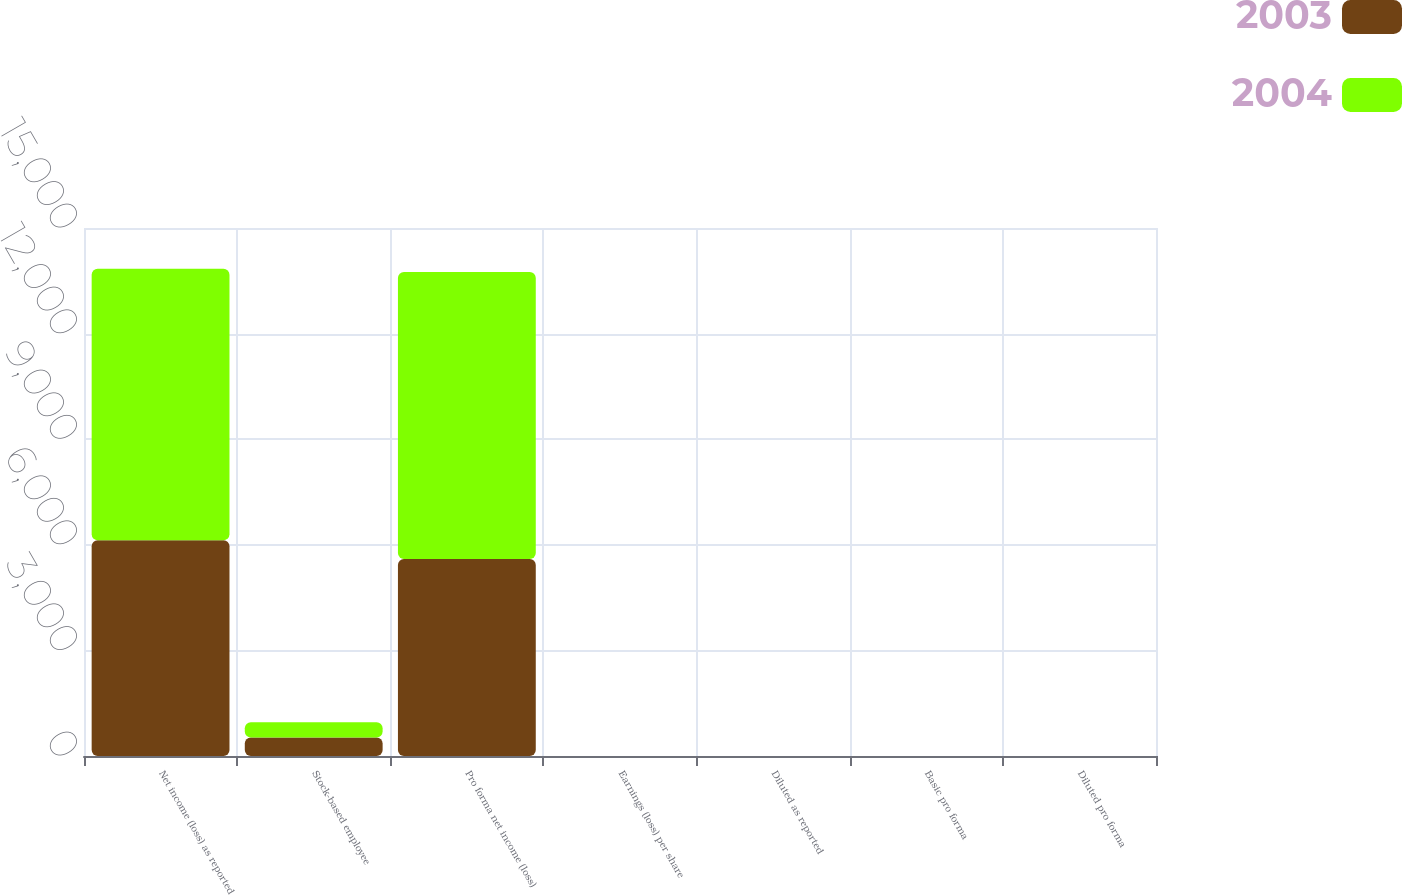<chart> <loc_0><loc_0><loc_500><loc_500><stacked_bar_chart><ecel><fcel>Net income (loss) as reported<fcel>Stock-based employee<fcel>Pro forma net income (loss)<fcel>Earnings (loss) per share<fcel>Diluted as reported<fcel>Basic pro forma<fcel>Diluted pro forma<nl><fcel>2003<fcel>6126<fcel>527<fcel>5599<fcel>0.24<fcel>0.24<fcel>0.22<fcel>0.22<nl><fcel>2004<fcel>7714<fcel>434<fcel>8148<fcel>0.34<fcel>0.34<fcel>0.36<fcel>0.36<nl></chart> 